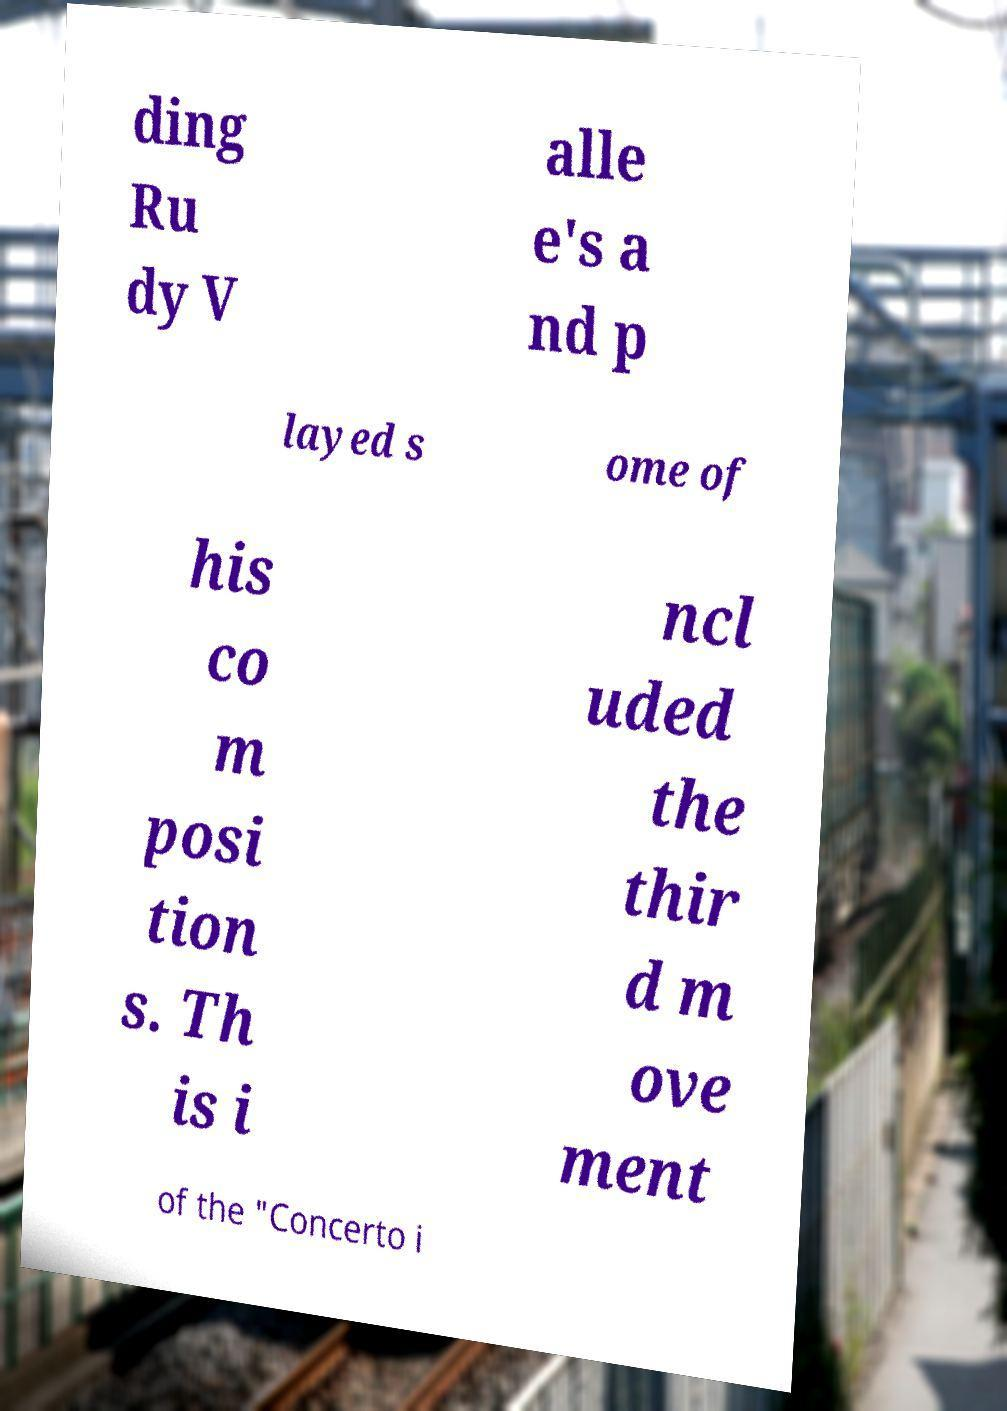Can you accurately transcribe the text from the provided image for me? ding Ru dy V alle e's a nd p layed s ome of his co m posi tion s. Th is i ncl uded the thir d m ove ment of the "Concerto i 